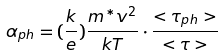Convert formula to latex. <formula><loc_0><loc_0><loc_500><loc_500>\alpha _ { p h } = ( \frac { k } { e } ) \frac { m ^ { * } v ^ { 2 } } { k T } \cdot \frac { < \tau _ { p h } > } { < \tau > }</formula> 